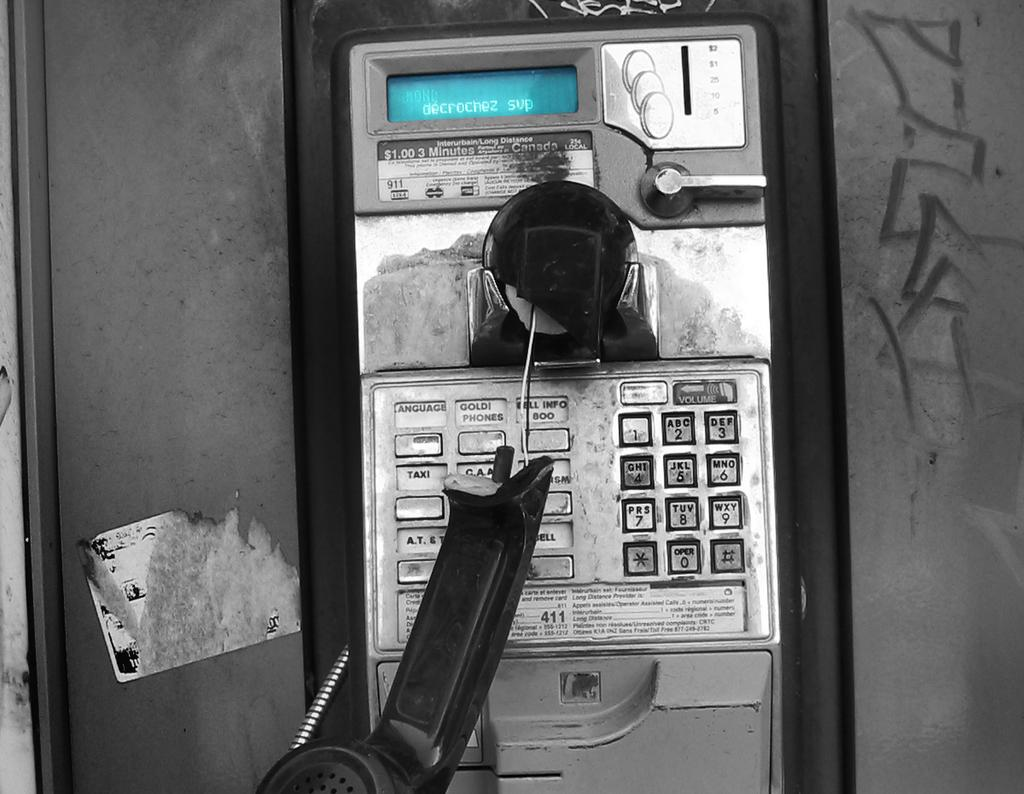<image>
Create a compact narrative representing the image presented. A broken pay phone says $1.00 for 3 minutes. 